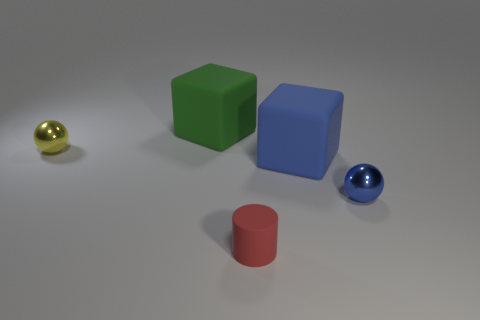The ball that is left of the small sphere right of the big rubber cube that is left of the red cylinder is what color?
Provide a succinct answer. Yellow. Are there fewer tiny yellow metal objects on the left side of the tiny blue shiny sphere than blue metal things?
Keep it short and to the point. No. How many small brown matte things are there?
Keep it short and to the point. 0. There is a green object on the right side of the tiny shiny thing that is to the left of the red object; what shape is it?
Your answer should be very brief. Cube. How many tiny blue shiny balls are behind the yellow object?
Make the answer very short. 0. Do the big blue thing and the small red thing right of the large green object have the same material?
Keep it short and to the point. Yes. Are there any blue matte cylinders of the same size as the red rubber cylinder?
Provide a short and direct response. No. Are there an equal number of tiny red things behind the blue matte object and green metallic cylinders?
Provide a short and direct response. Yes. The green block is what size?
Provide a succinct answer. Large. How many cubes are in front of the shiny sphere behind the blue cube?
Your answer should be very brief. 1. 